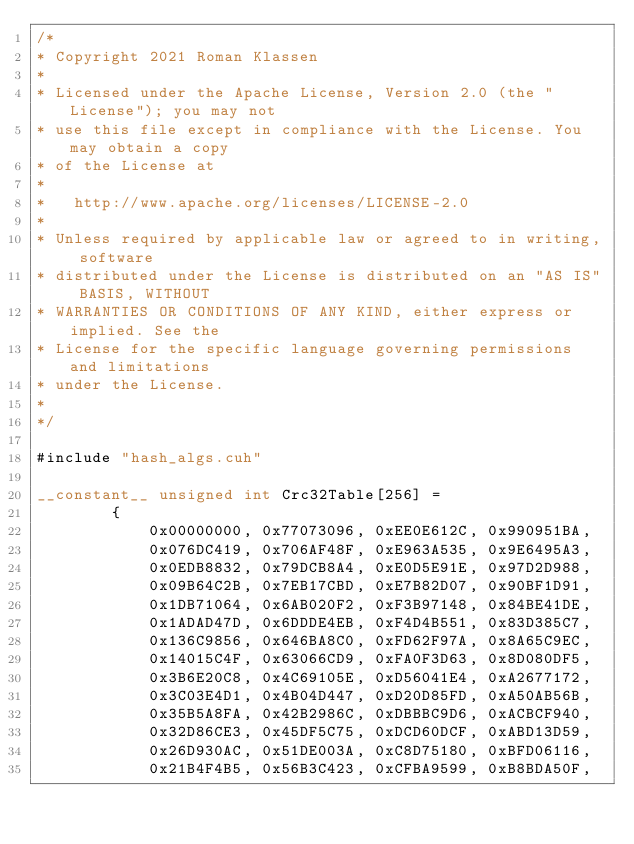<code> <loc_0><loc_0><loc_500><loc_500><_Cuda_>/*
* Copyright 2021 Roman Klassen
*
* Licensed under the Apache License, Version 2.0 (the "License"); you may not
* use this file except in compliance with the License. You may obtain a copy
* of the License at
*
*   http://www.apache.org/licenses/LICENSE-2.0
*
* Unless required by applicable law or agreed to in writing, software
* distributed under the License is distributed on an "AS IS" BASIS, WITHOUT
* WARRANTIES OR CONDITIONS OF ANY KIND, either express or implied. See the
* License for the specific language governing permissions and limitations
* under the License.
*
*/

#include "hash_algs.cuh"

__constant__ unsigned int Crc32Table[256] = 
        {
            0x00000000, 0x77073096, 0xEE0E612C, 0x990951BA,
            0x076DC419, 0x706AF48F, 0xE963A535, 0x9E6495A3,
            0x0EDB8832, 0x79DCB8A4, 0xE0D5E91E, 0x97D2D988,
            0x09B64C2B, 0x7EB17CBD, 0xE7B82D07, 0x90BF1D91,
            0x1DB71064, 0x6AB020F2, 0xF3B97148, 0x84BE41DE,
            0x1ADAD47D, 0x6DDDE4EB, 0xF4D4B551, 0x83D385C7,
            0x136C9856, 0x646BA8C0, 0xFD62F97A, 0x8A65C9EC,
            0x14015C4F, 0x63066CD9, 0xFA0F3D63, 0x8D080DF5,
            0x3B6E20C8, 0x4C69105E, 0xD56041E4, 0xA2677172,
            0x3C03E4D1, 0x4B04D447, 0xD20D85FD, 0xA50AB56B,
            0x35B5A8FA, 0x42B2986C, 0xDBBBC9D6, 0xACBCF940,
            0x32D86CE3, 0x45DF5C75, 0xDCD60DCF, 0xABD13D59,
            0x26D930AC, 0x51DE003A, 0xC8D75180, 0xBFD06116,
            0x21B4F4B5, 0x56B3C423, 0xCFBA9599, 0xB8BDA50F,</code> 